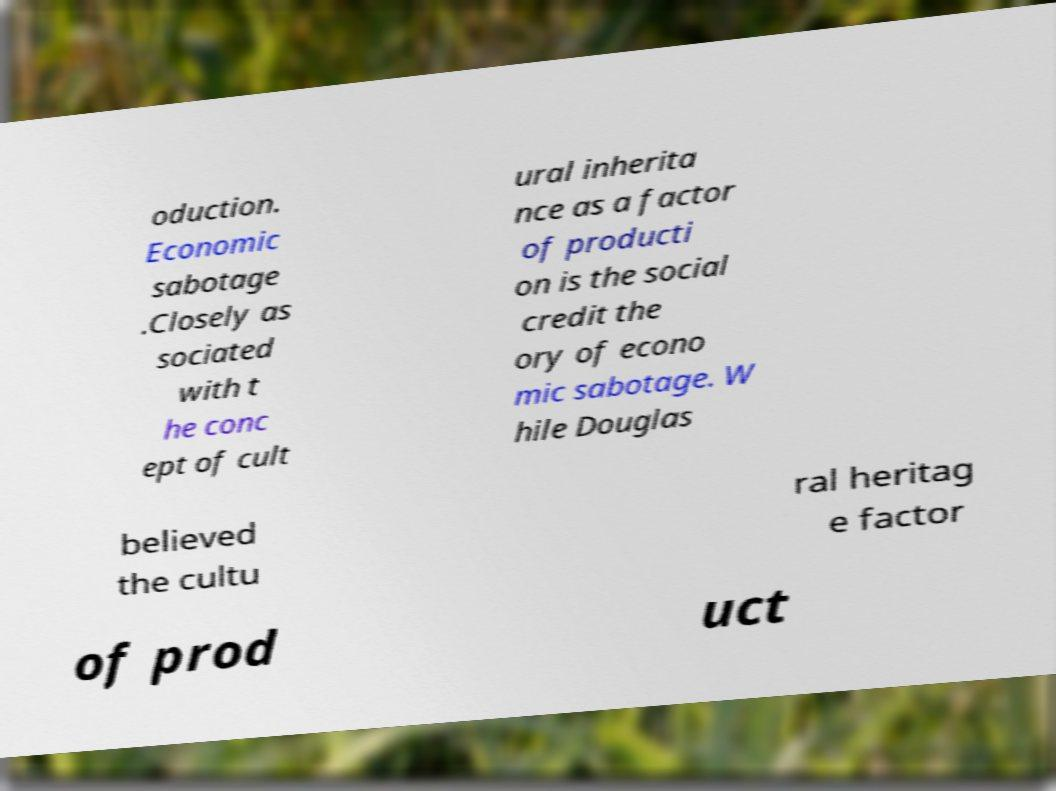Could you extract and type out the text from this image? oduction. Economic sabotage .Closely as sociated with t he conc ept of cult ural inherita nce as a factor of producti on is the social credit the ory of econo mic sabotage. W hile Douglas believed the cultu ral heritag e factor of prod uct 